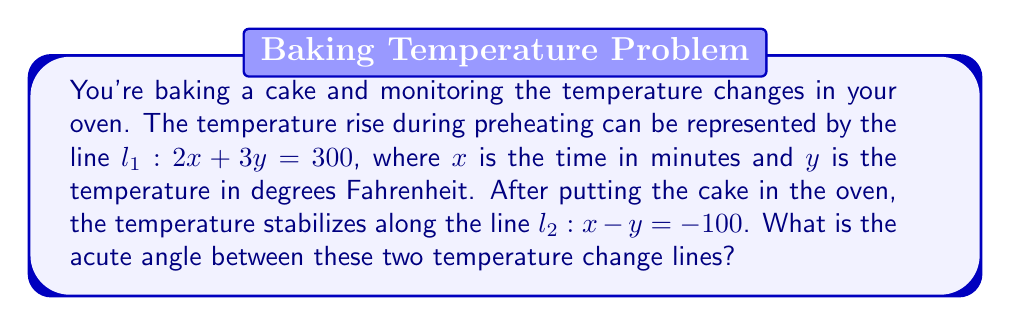Could you help me with this problem? To find the angle between two lines, we can use the formula:

$$ \tan \theta = \left|\frac{m_2 - m_1}{1 + m_1m_2}\right| $$

where $m_1$ and $m_2$ are the slopes of the two lines.

1. First, let's find the slopes of both lines:

   For $l_1: 2x + 3y = 300$, rearrange to slope-intercept form:
   $y = -\frac{2}{3}x + 100$, so $m_1 = -\frac{2}{3}$

   For $l_2: x - y = -100$, rearrange to slope-intercept form:
   $y = x + 100$, so $m_2 = 1$

2. Now, let's substitute these values into the formula:

   $$ \tan \theta = \left|\frac{1 - (-\frac{2}{3})}{1 + (-\frac{2}{3})(1)}\right| = \left|\frac{1 + \frac{2}{3}}{1 - \frac{2}{3}}\right| = \left|\frac{\frac{5}{3}}{\frac{1}{3}}\right| = 5 $$

3. To find $\theta$, we need to take the inverse tangent (arctangent):

   $$ \theta = \tan^{-1}(5) $$

4. Using a calculator or trigonometric tables:

   $$ \theta \approx 78.69^\circ $$

This is the acute angle between the two lines representing the temperature changes in your oven.
Answer: The acute angle between the two temperature change lines is approximately $78.69^\circ$. 